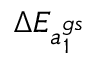Convert formula to latex. <formula><loc_0><loc_0><loc_500><loc_500>{ \Delta E _ { a _ { 1 } ^ { g s } } }</formula> 